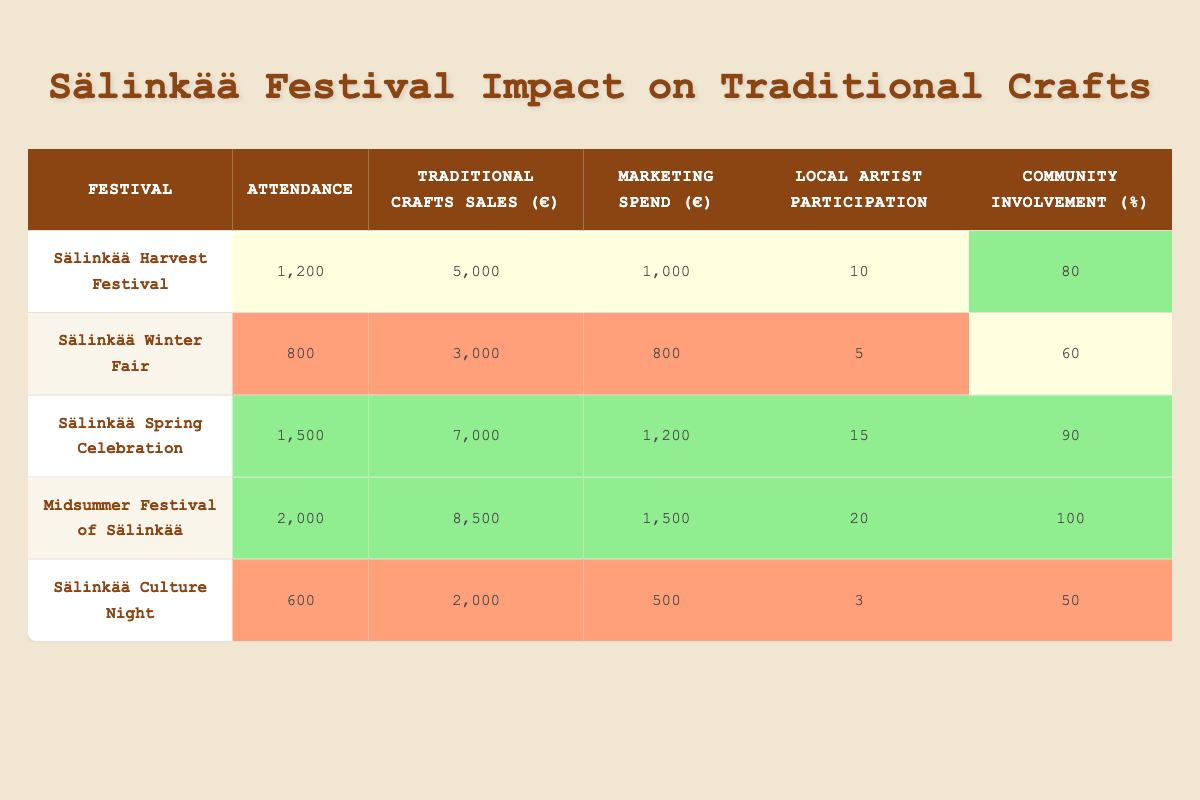What festival had the highest attendance? By examining the attendance numbers in the table, we can see the Midsummer Festival of Sälinkää has the largest attendance recorded at 2000.
Answer: Midsummer Festival of Sälinkää What is the total traditional crafts sales for all festivals combined? To find the total, we sum the sales values: 5000 + 3000 + 7000 + 8500 + 2000 = 25500.
Answer: 25500 Did the Sälinkää Winter Fair have a higher traditional crafts sales than the Sälinkää Culture Night? Comparing the sales, the Winter Fair recorded 3000 while the Culture Night had 2000. Since 3000 is greater than 2000, the statement is true.
Answer: Yes What is the average community involvement percentage across all festivals? We extract the community involvement percentages: 80, 60, 90, 100, 50. The sum is 80 + 60 + 90 + 100 + 50 = 380. There are 5 festivals, so the average is 380/5 = 76.
Answer: 76 Which festival had the highest marketing spend? Looking at the marketing spend column, Midsummer Festival of Sälinkää has the highest figure at 1500.
Answer: Midsummer Festival of Sälinkää Is it true that the festivals with higher attendance also had greater traditional crafts sales? Analyzing the data, it appears that as attendance increases, the sales also tend to increase. For example, Midsummer Festival has the highest values in both categories. Therefore, the statement holds true.
Answer: Yes Calculate the difference in traditional crafts sales between the Sälinkää Spring Celebration and the Sälinkää Winter Fair. The sales for the Spring Celebration is 7000 and for the Winter Fair is 3000. The difference is 7000 - 3000 = 4000.
Answer: 4000 What is the maximum number of local artist participation found in the given festivals? Checking the local artist participation column, the Midsummer Festival of Sälinkää has the highest participation at 20.
Answer: 20 Does the Sälinkää Harvest Festival have a community involvement percentage above the average? The community involvement percentage for the Harvest Festival is 80, while the average calculated is 76. Since 80 is greater than 76, the statement is true.
Answer: Yes 